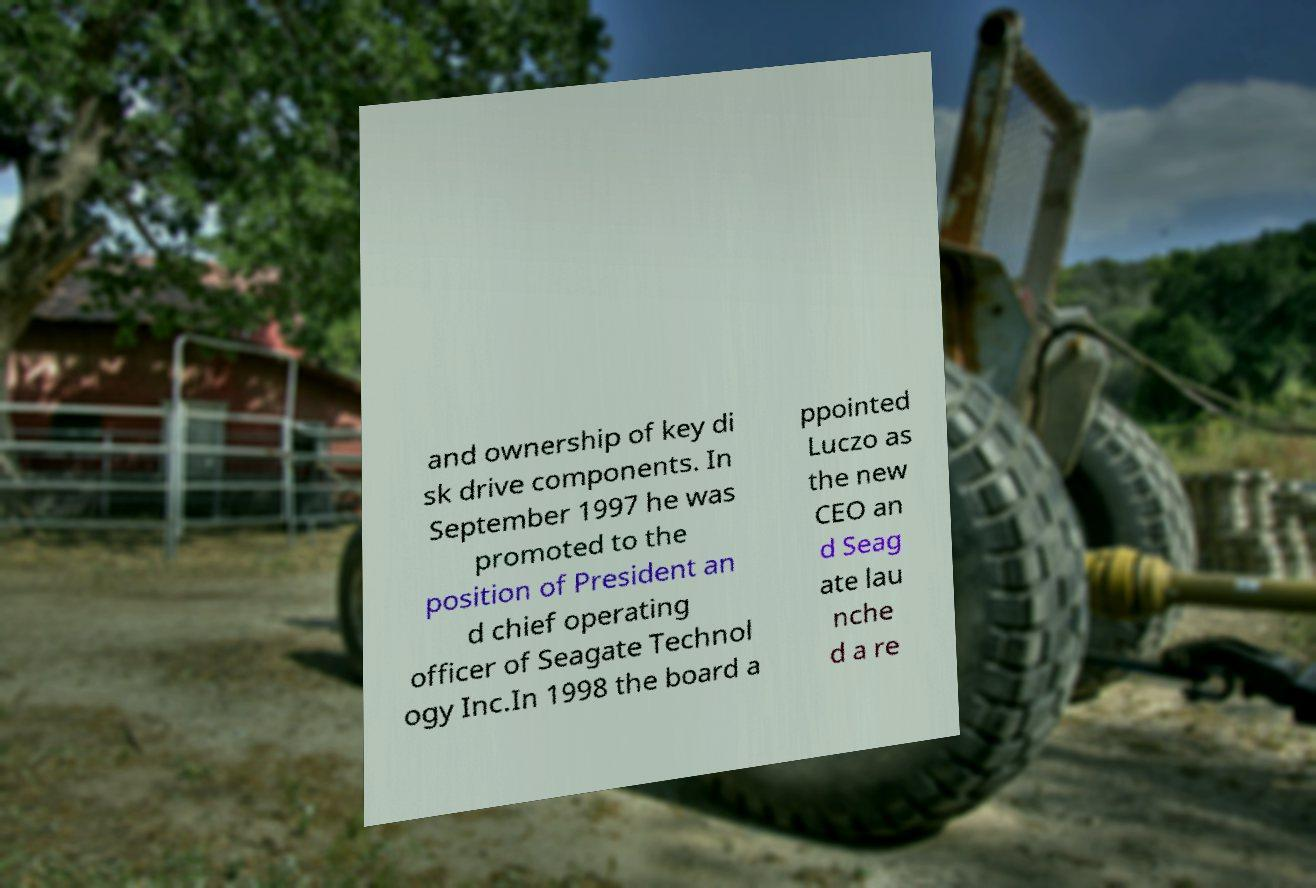Could you assist in decoding the text presented in this image and type it out clearly? and ownership of key di sk drive components. In September 1997 he was promoted to the position of President an d chief operating officer of Seagate Technol ogy Inc.In 1998 the board a ppointed Luczo as the new CEO an d Seag ate lau nche d a re 